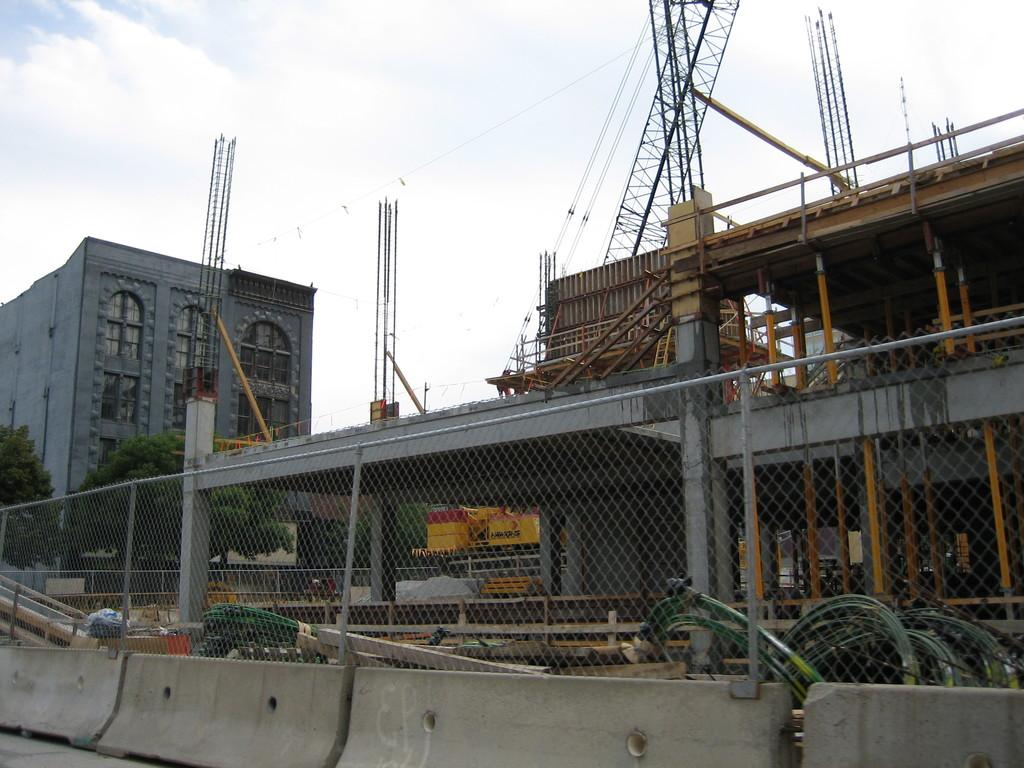What type of structure can be seen in the image? There is a fencing in the image. What is located behind the fencing? There is a construction behind the fencing. What can be seen in the background of the image? There are trees and a building in the background of the image. Can you see a horse jumping over the fencing in the image? There is no horse present in the image, so it cannot be seen jumping over the fencing. 